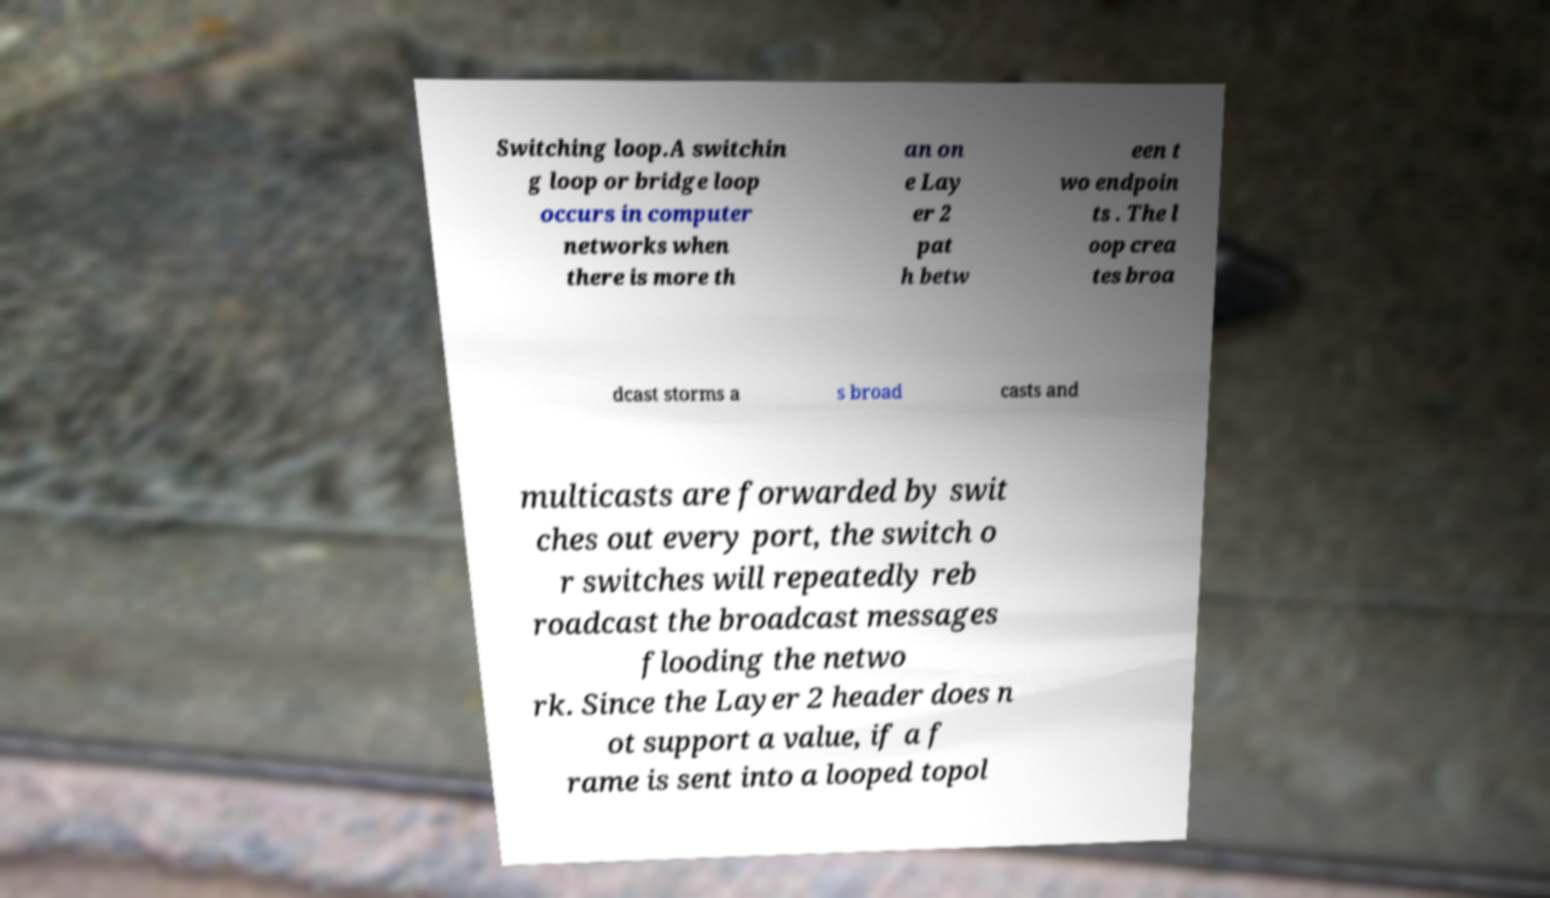There's text embedded in this image that I need extracted. Can you transcribe it verbatim? Switching loop.A switchin g loop or bridge loop occurs in computer networks when there is more th an on e Lay er 2 pat h betw een t wo endpoin ts . The l oop crea tes broa dcast storms a s broad casts and multicasts are forwarded by swit ches out every port, the switch o r switches will repeatedly reb roadcast the broadcast messages flooding the netwo rk. Since the Layer 2 header does n ot support a value, if a f rame is sent into a looped topol 